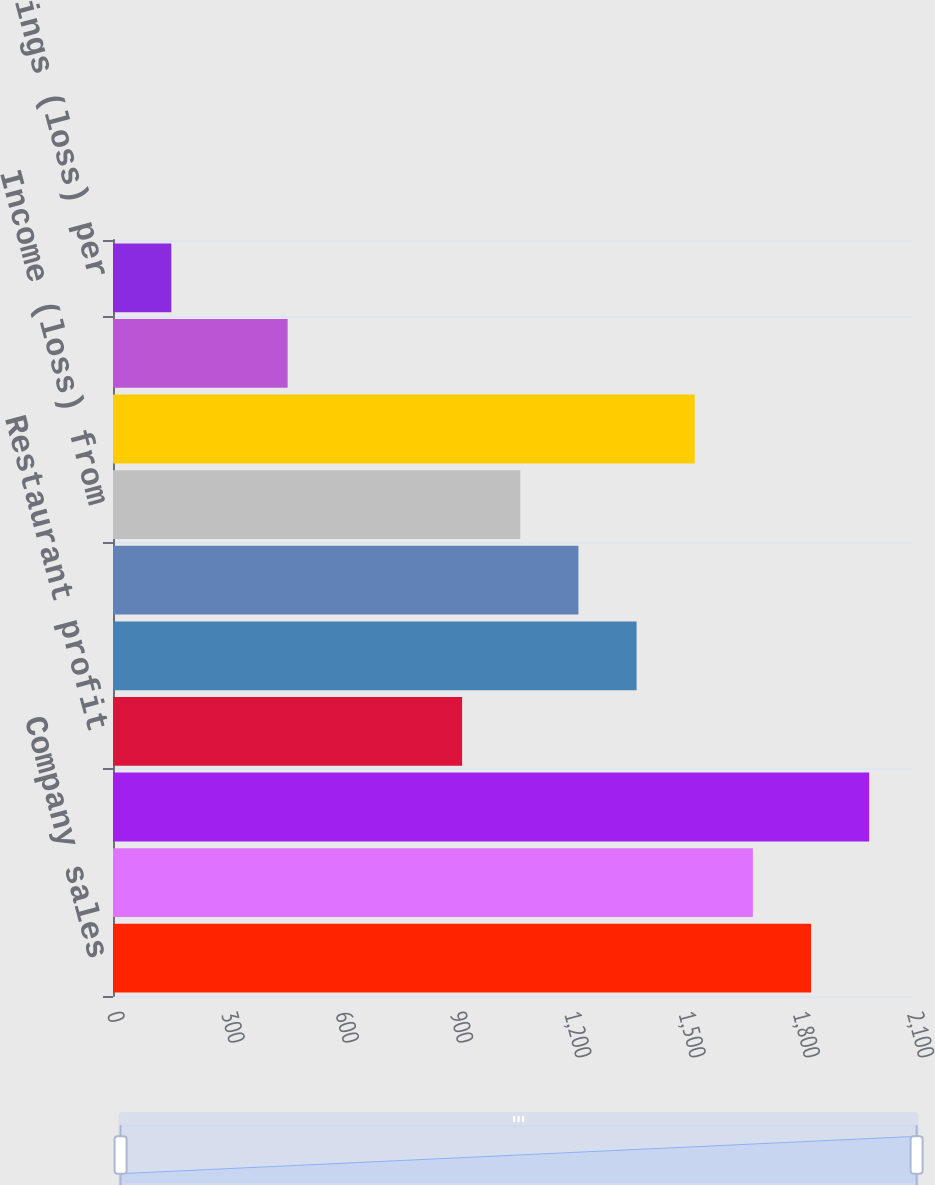<chart> <loc_0><loc_0><loc_500><loc_500><bar_chart><fcel>Company sales<fcel>Franchise and license fees and<fcel>Total revenues<fcel>Restaurant profit<fcel>Operating Profit (b)<fcel>Income from continuing<fcel>Income (loss) from<fcel>Net Income<fcel>Basic earnings per common<fcel>Basic earnings (loss) per<nl><fcel>1832.35<fcel>1679.69<fcel>1985.01<fcel>916.39<fcel>1374.37<fcel>1221.71<fcel>1069.05<fcel>1527.03<fcel>458.41<fcel>153.09<nl></chart> 